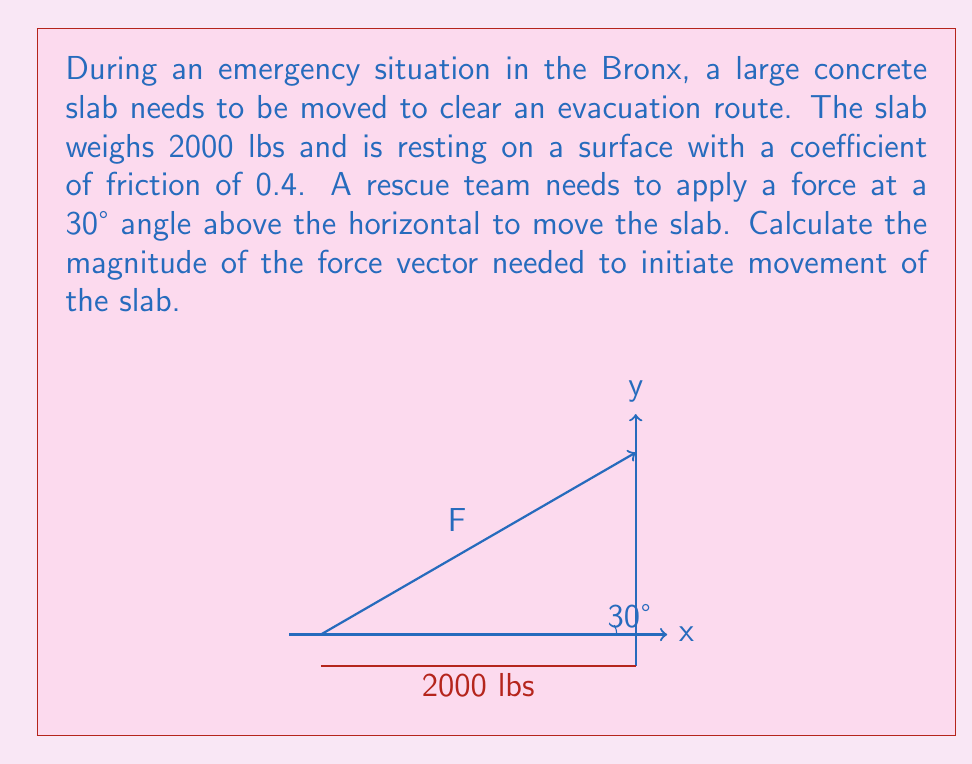Teach me how to tackle this problem. Let's approach this step-by-step:

1) First, we need to determine the normal force. Since the slab is on a horizontal surface, the normal force equals the weight of the slab:

   $N = 2000 \text{ lbs}$

2) The maximum static friction force is given by:

   $f_s = \mu N = 0.4 \times 2000 = 800 \text{ lbs}$

3) Let the required force be $F$. We can decompose this force into horizontal and vertical components:

   $F_x = F \cos 30°$
   $F_y = F \sin 30°$

4) The vertical component of $F$ reduces the normal force:

   $N_{new} = 2000 - F \sin 30°$

5) For the slab to start moving, the horizontal component of $F$ must exceed the new friction force:

   $F \cos 30° > 0.4(2000 - F \sin 30°)$

6) At the point of impending motion, we can replace '>' with '=':

   $F \cos 30° = 0.4(2000 - F \sin 30°)$

7) Simplify using $\cos 30° = \frac{\sqrt{3}}{2}$ and $\sin 30° = \frac{1}{2}$:

   $F \cdot \frac{\sqrt{3}}{2} = 800 - 0.2F$

8) Solve for $F$:

   $F \cdot \frac{\sqrt{3}}{2} + 0.2F = 800$
   $F(\frac{\sqrt{3}}{2} + 0.2) = 800$
   $F = \frac{800}{\frac{\sqrt{3}}{2} + 0.2} \approx 1155.4 \text{ lbs}$

Therefore, a force of approximately 1155.4 lbs at a 30° angle above the horizontal is needed to initiate movement of the slab.
Answer: $F \approx 1155.4 \text{ lbs}$ 